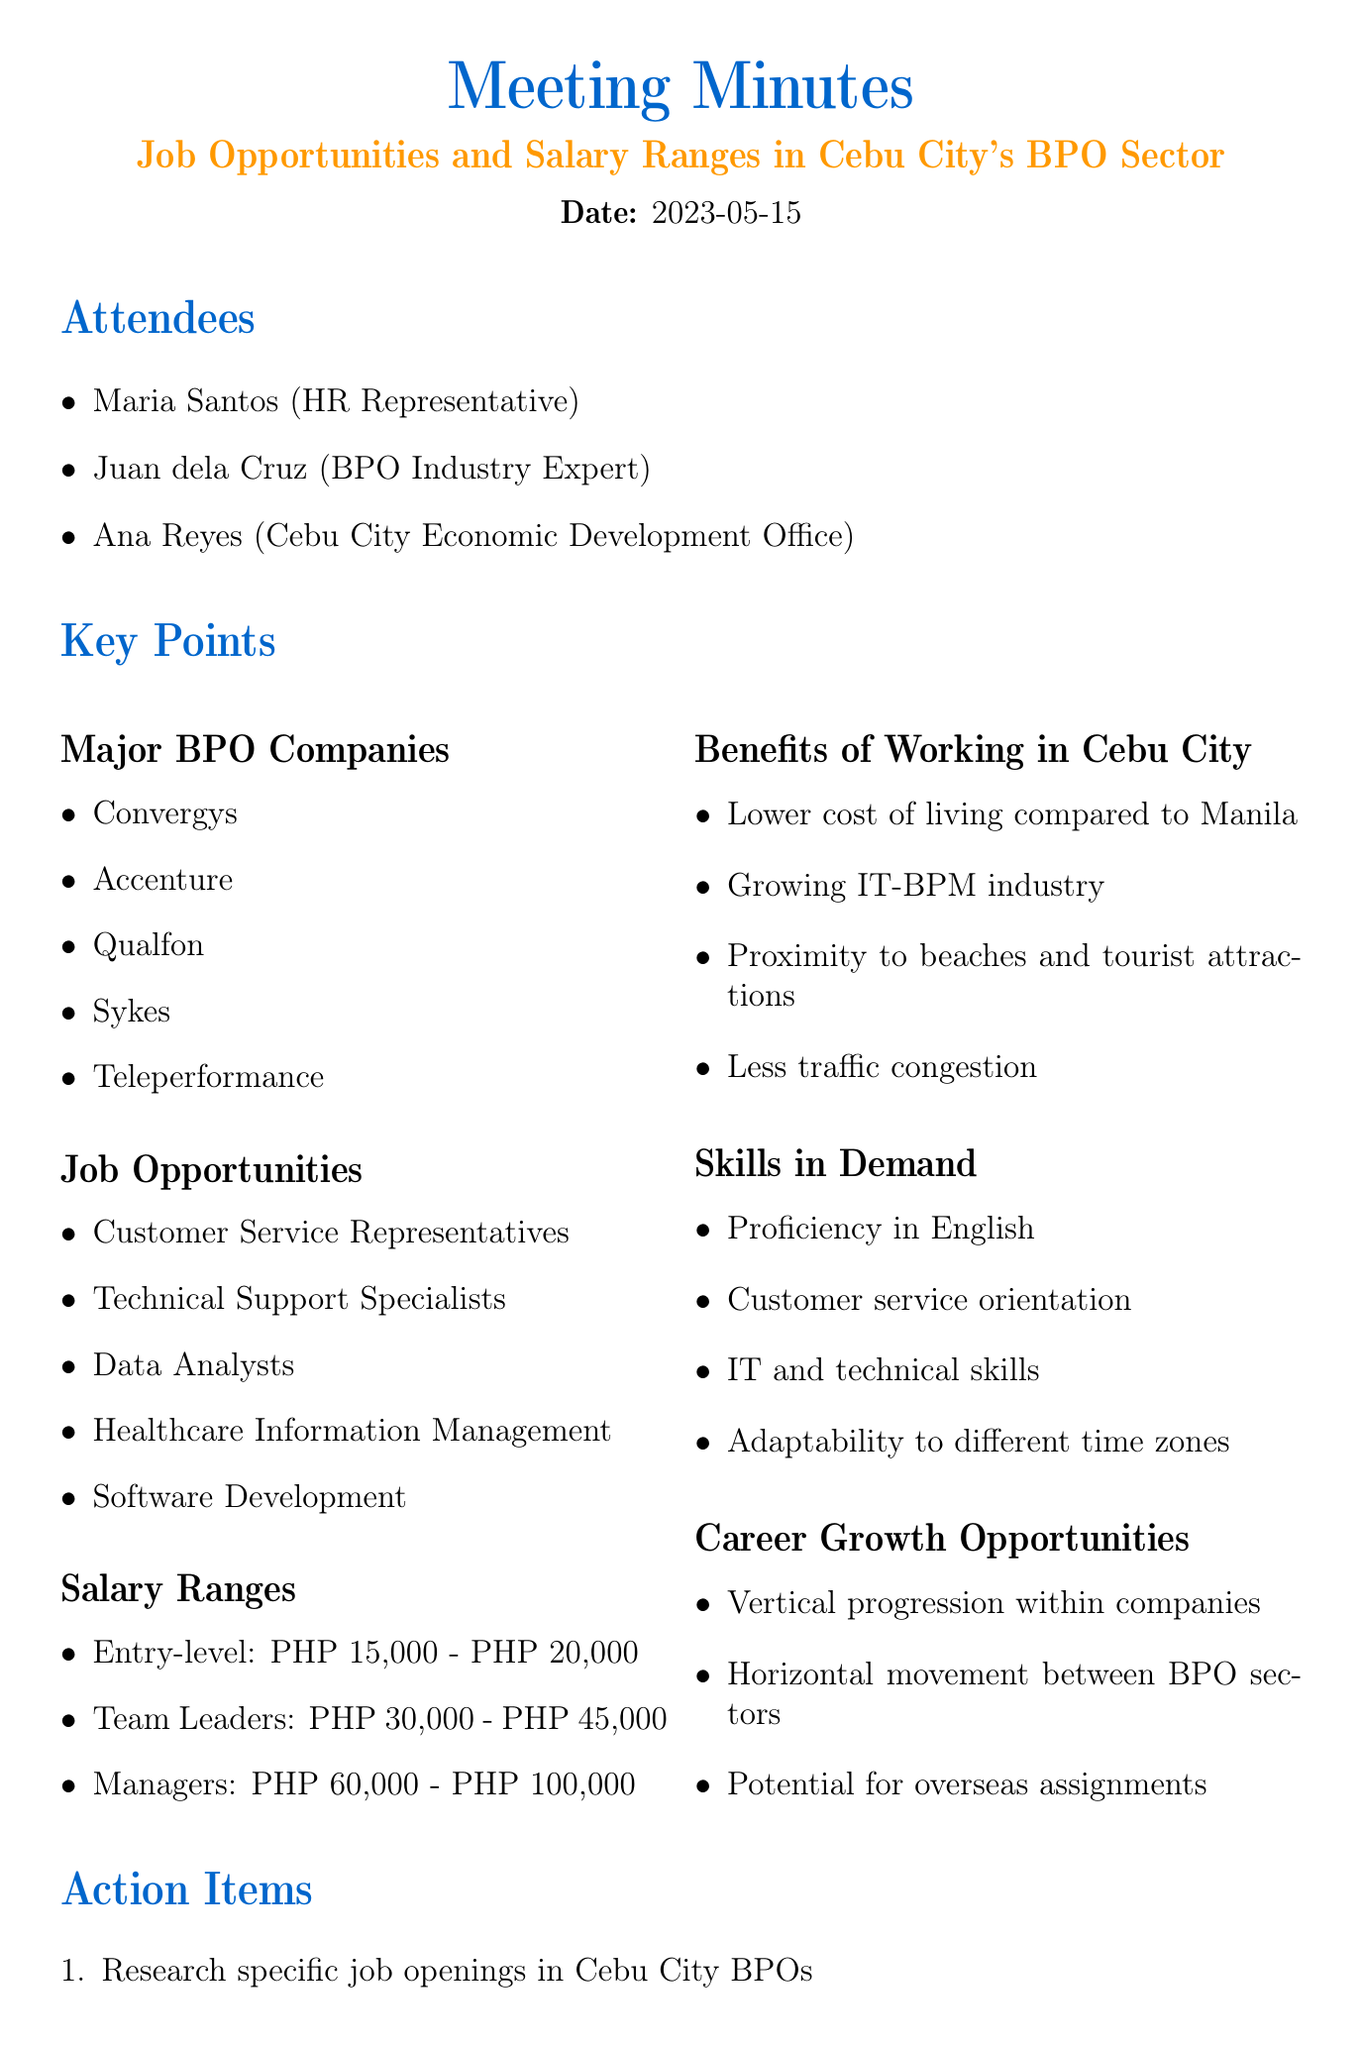What is the date of the meeting? The date of the meeting is explicitly stated in the document.
Answer: 2023-05-15 Who is the HR Representative? The document lists the attendees along with their roles, including the HR Representative.
Answer: Maria Santos What are the job opportunities mentioned? The document details various job opportunities available in Cebu City’s BPO sector.
Answer: Customer Service Representatives, Technical Support Specialists, Data Analysts, Healthcare Information Management, Software Development What is the salary range for Entry-level positions? The document provides specific salary ranges for different job levels in the BPO sector.
Answer: PHP 15,000 - PHP 20,000 Which company is listed as a major BPO in Cebu City? The document lists several major BPO companies, and one of them can be cited.
Answer: Convergys What are the benefits of working in Cebu City? The document outlines various benefits, requiring a summary of the listed details.
Answer: Lower cost of living compared to Manila, Growing IT-BPM industry, Proximity to beaches and tourist attractions, Less traffic congestion What skills are in demand according to the document? The document identifies specific skills required in the BPO sector, which can be directly listed.
Answer: Proficiency in English, Customer service orientation, IT and technical skills, Adaptability to different time zones What are the action items from the meeting? The action items listed in the document outline specific follow-up tasks resulting from the discussion.
Answer: Research specific job openings in Cebu City BPOs, Update resume to highlight relevant skills, Contact Cebu City Economic Development Office for more information on relocation support How many attendees were present at the meeting? The number of attendees can be determined by counting the names listed in the document.
Answer: 3 